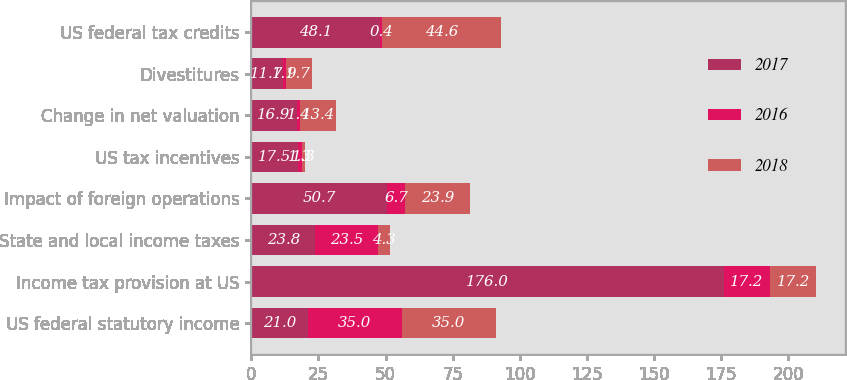<chart> <loc_0><loc_0><loc_500><loc_500><stacked_bar_chart><ecel><fcel>US federal statutory income<fcel>Income tax provision at US<fcel>State and local income taxes<fcel>Impact of foreign operations<fcel>US tax incentives<fcel>Change in net valuation<fcel>Divestitures<fcel>US federal tax credits<nl><fcel>2017<fcel>21<fcel>176<fcel>23.8<fcel>50.7<fcel>17.5<fcel>16.9<fcel>11.7<fcel>48.1<nl><fcel>2016<fcel>35<fcel>17.2<fcel>23.5<fcel>6.7<fcel>1.3<fcel>1.4<fcel>1.1<fcel>0.4<nl><fcel>2018<fcel>35<fcel>17.2<fcel>4.3<fcel>23.9<fcel>1.3<fcel>13.4<fcel>9.7<fcel>44.6<nl></chart> 